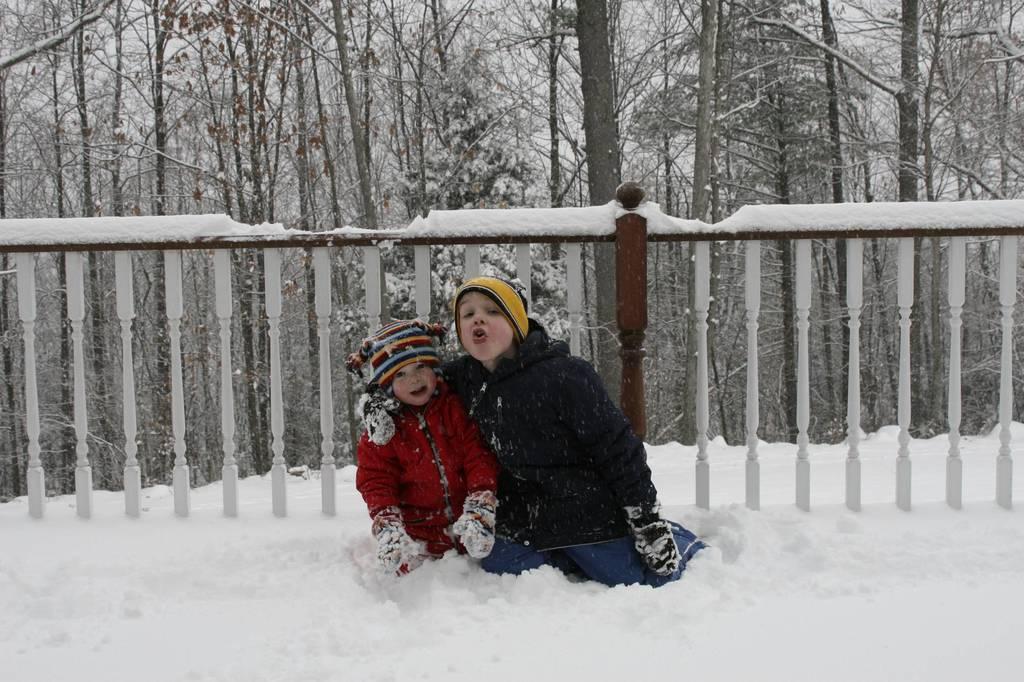In one or two sentences, can you explain what this image depicts? In this picture, we see two children who are wearing the red and black jackets are sitting in the ice. They might be posing for the photo. At the bottom, we see the ice. Behind them, we see the railing. There are trees in the background and these trees are covered with the ice. 